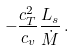<formula> <loc_0><loc_0><loc_500><loc_500>- \frac { c _ { T } ^ { 2 } } { c _ { v } } \frac { L _ { s } } { \dot { M } } \, .</formula> 